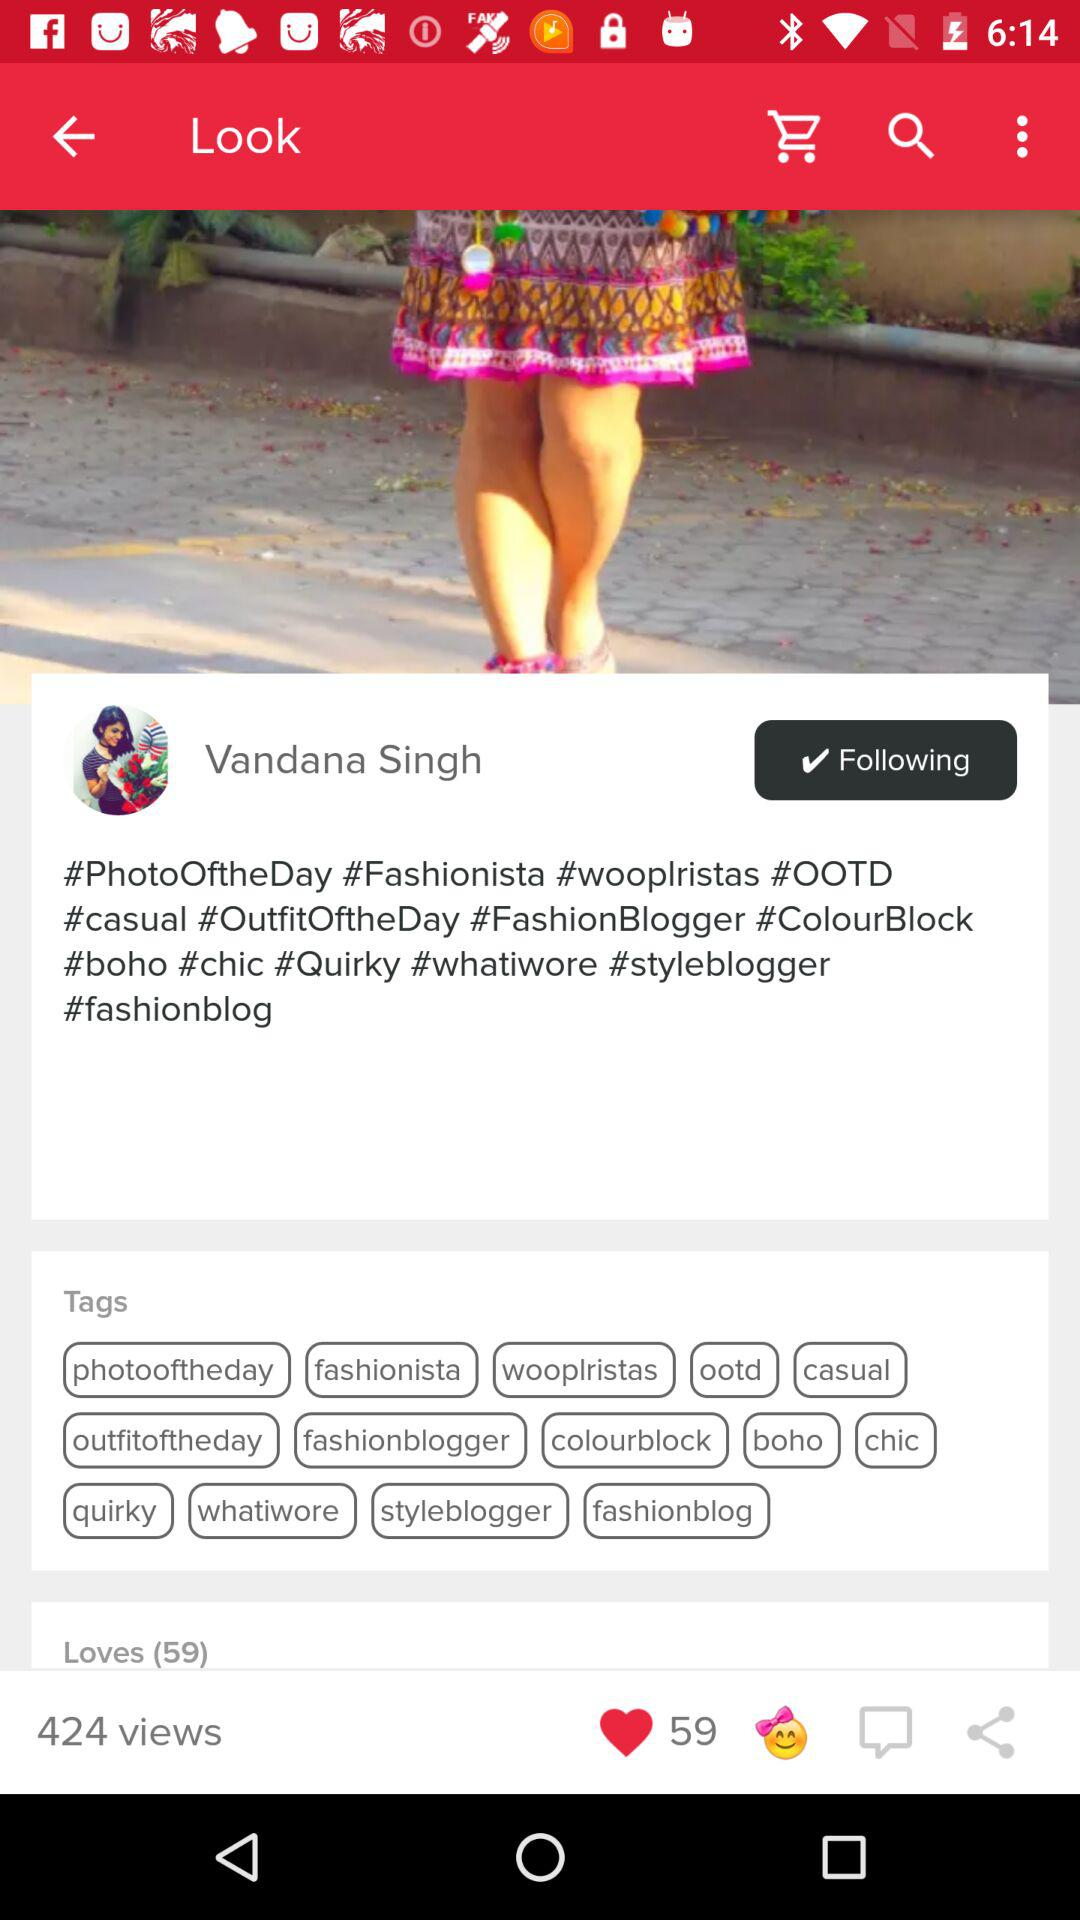How many people liked the post? The number of people who liked the post is 59. 